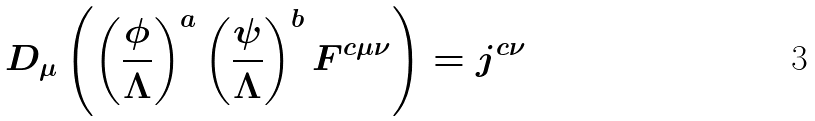<formula> <loc_0><loc_0><loc_500><loc_500>D _ { \mu } \left ( \left ( \frac { \phi } { \Lambda } \right ) ^ { a } \left ( \frac { \psi } { \Lambda } \right ) ^ { b } F ^ { c \mu \nu } \right ) = j ^ { c \nu }</formula> 